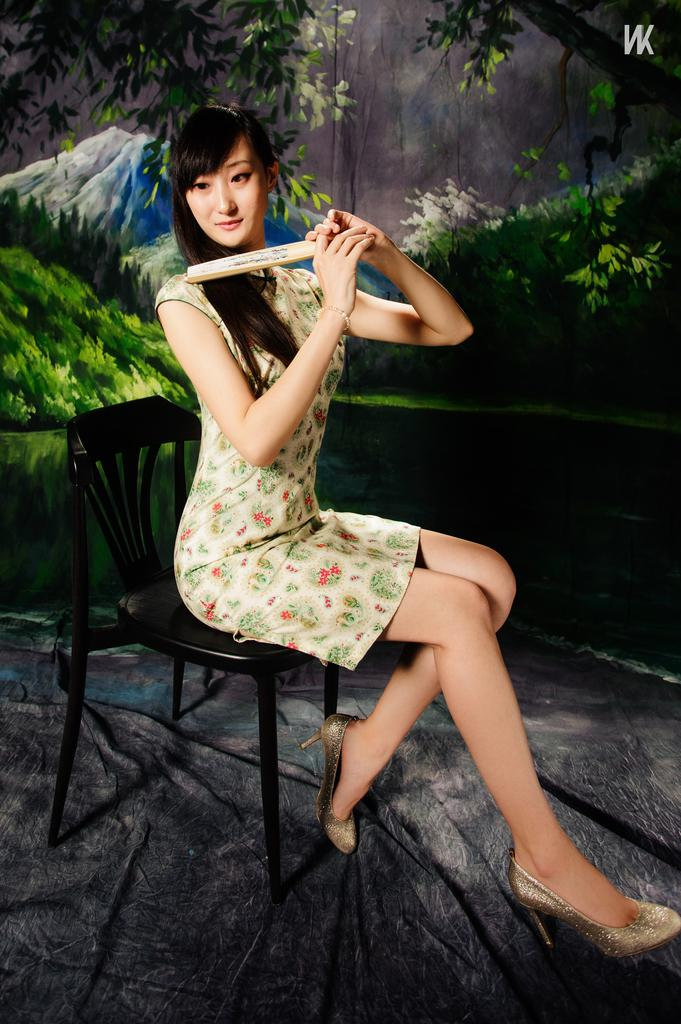Who is present in the image? There is a woman in the image. What is the woman doing in the image? The woman is sitting on a chair. What can be seen in the background of the image? There are trees and mountains in the background of the image. What type of house can be seen in the image? There is no house present in the image; it features a woman sitting on a chair with trees and mountains in the background. What structure is visible in the image? The image does not show any specific structure; it only shows a woman sitting on a chair with trees and mountains in the background. 